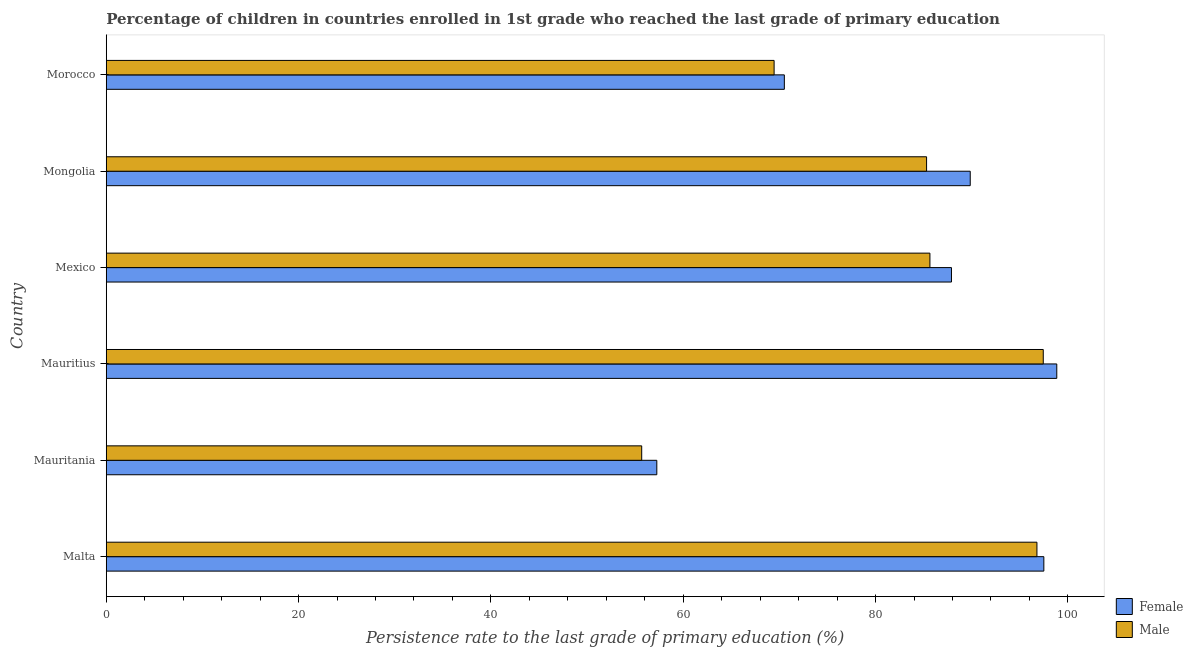Are the number of bars on each tick of the Y-axis equal?
Provide a succinct answer. Yes. How many bars are there on the 5th tick from the top?
Ensure brevity in your answer.  2. What is the label of the 1st group of bars from the top?
Your answer should be compact. Morocco. In how many cases, is the number of bars for a given country not equal to the number of legend labels?
Offer a very short reply. 0. What is the persistence rate of male students in Morocco?
Make the answer very short. 69.45. Across all countries, what is the maximum persistence rate of female students?
Your response must be concise. 98.84. Across all countries, what is the minimum persistence rate of female students?
Provide a short and direct response. 57.25. In which country was the persistence rate of male students maximum?
Make the answer very short. Mauritius. In which country was the persistence rate of male students minimum?
Make the answer very short. Mauritania. What is the total persistence rate of female students in the graph?
Provide a succinct answer. 501.84. What is the difference between the persistence rate of male students in Malta and that in Mauritius?
Your answer should be compact. -0.66. What is the difference between the persistence rate of female students in Malta and the persistence rate of male students in Mauritius?
Make the answer very short. 0.06. What is the average persistence rate of female students per country?
Your answer should be compact. 83.64. What is the difference between the persistence rate of male students and persistence rate of female students in Malta?
Ensure brevity in your answer.  -0.72. In how many countries, is the persistence rate of male students greater than 36 %?
Give a very brief answer. 6. Is the difference between the persistence rate of female students in Mauritania and Mongolia greater than the difference between the persistence rate of male students in Mauritania and Mongolia?
Give a very brief answer. No. What is the difference between the highest and the second highest persistence rate of female students?
Your answer should be compact. 1.34. What is the difference between the highest and the lowest persistence rate of female students?
Offer a terse response. 41.59. In how many countries, is the persistence rate of female students greater than the average persistence rate of female students taken over all countries?
Your answer should be very brief. 4. What does the 2nd bar from the top in Malta represents?
Your answer should be compact. Female. What is the difference between two consecutive major ticks on the X-axis?
Your answer should be compact. 20. Does the graph contain grids?
Make the answer very short. No. How are the legend labels stacked?
Offer a very short reply. Vertical. What is the title of the graph?
Make the answer very short. Percentage of children in countries enrolled in 1st grade who reached the last grade of primary education. What is the label or title of the X-axis?
Make the answer very short. Persistence rate to the last grade of primary education (%). What is the label or title of the Y-axis?
Make the answer very short. Country. What is the Persistence rate to the last grade of primary education (%) in Female in Malta?
Offer a terse response. 97.5. What is the Persistence rate to the last grade of primary education (%) of Male in Malta?
Offer a terse response. 96.78. What is the Persistence rate to the last grade of primary education (%) of Female in Mauritania?
Your answer should be compact. 57.25. What is the Persistence rate to the last grade of primary education (%) in Male in Mauritania?
Ensure brevity in your answer.  55.68. What is the Persistence rate to the last grade of primary education (%) of Female in Mauritius?
Offer a very short reply. 98.84. What is the Persistence rate to the last grade of primary education (%) in Male in Mauritius?
Provide a succinct answer. 97.44. What is the Persistence rate to the last grade of primary education (%) of Female in Mexico?
Give a very brief answer. 87.89. What is the Persistence rate to the last grade of primary education (%) in Male in Mexico?
Give a very brief answer. 85.65. What is the Persistence rate to the last grade of primary education (%) in Female in Mongolia?
Offer a very short reply. 89.84. What is the Persistence rate to the last grade of primary education (%) in Male in Mongolia?
Give a very brief answer. 85.3. What is the Persistence rate to the last grade of primary education (%) of Female in Morocco?
Provide a succinct answer. 70.51. What is the Persistence rate to the last grade of primary education (%) in Male in Morocco?
Offer a terse response. 69.45. Across all countries, what is the maximum Persistence rate to the last grade of primary education (%) of Female?
Keep it short and to the point. 98.84. Across all countries, what is the maximum Persistence rate to the last grade of primary education (%) of Male?
Give a very brief answer. 97.44. Across all countries, what is the minimum Persistence rate to the last grade of primary education (%) of Female?
Provide a succinct answer. 57.25. Across all countries, what is the minimum Persistence rate to the last grade of primary education (%) in Male?
Offer a terse response. 55.68. What is the total Persistence rate to the last grade of primary education (%) of Female in the graph?
Give a very brief answer. 501.84. What is the total Persistence rate to the last grade of primary education (%) of Male in the graph?
Provide a short and direct response. 490.3. What is the difference between the Persistence rate to the last grade of primary education (%) of Female in Malta and that in Mauritania?
Keep it short and to the point. 40.25. What is the difference between the Persistence rate to the last grade of primary education (%) of Male in Malta and that in Mauritania?
Ensure brevity in your answer.  41.1. What is the difference between the Persistence rate to the last grade of primary education (%) of Female in Malta and that in Mauritius?
Your response must be concise. -1.34. What is the difference between the Persistence rate to the last grade of primary education (%) of Male in Malta and that in Mauritius?
Offer a terse response. -0.66. What is the difference between the Persistence rate to the last grade of primary education (%) of Female in Malta and that in Mexico?
Your answer should be compact. 9.61. What is the difference between the Persistence rate to the last grade of primary education (%) of Male in Malta and that in Mexico?
Make the answer very short. 11.13. What is the difference between the Persistence rate to the last grade of primary education (%) in Female in Malta and that in Mongolia?
Make the answer very short. 7.65. What is the difference between the Persistence rate to the last grade of primary education (%) of Male in Malta and that in Mongolia?
Your answer should be compact. 11.48. What is the difference between the Persistence rate to the last grade of primary education (%) in Female in Malta and that in Morocco?
Your answer should be compact. 26.98. What is the difference between the Persistence rate to the last grade of primary education (%) in Male in Malta and that in Morocco?
Offer a terse response. 27.33. What is the difference between the Persistence rate to the last grade of primary education (%) of Female in Mauritania and that in Mauritius?
Make the answer very short. -41.59. What is the difference between the Persistence rate to the last grade of primary education (%) in Male in Mauritania and that in Mauritius?
Offer a terse response. -41.76. What is the difference between the Persistence rate to the last grade of primary education (%) in Female in Mauritania and that in Mexico?
Offer a terse response. -30.64. What is the difference between the Persistence rate to the last grade of primary education (%) of Male in Mauritania and that in Mexico?
Give a very brief answer. -29.97. What is the difference between the Persistence rate to the last grade of primary education (%) of Female in Mauritania and that in Mongolia?
Keep it short and to the point. -32.59. What is the difference between the Persistence rate to the last grade of primary education (%) of Male in Mauritania and that in Mongolia?
Provide a short and direct response. -29.62. What is the difference between the Persistence rate to the last grade of primary education (%) in Female in Mauritania and that in Morocco?
Provide a succinct answer. -13.26. What is the difference between the Persistence rate to the last grade of primary education (%) of Male in Mauritania and that in Morocco?
Offer a very short reply. -13.77. What is the difference between the Persistence rate to the last grade of primary education (%) of Female in Mauritius and that in Mexico?
Offer a terse response. 10.95. What is the difference between the Persistence rate to the last grade of primary education (%) of Male in Mauritius and that in Mexico?
Offer a very short reply. 11.79. What is the difference between the Persistence rate to the last grade of primary education (%) in Female in Mauritius and that in Mongolia?
Keep it short and to the point. 9. What is the difference between the Persistence rate to the last grade of primary education (%) of Male in Mauritius and that in Mongolia?
Your response must be concise. 12.13. What is the difference between the Persistence rate to the last grade of primary education (%) in Female in Mauritius and that in Morocco?
Offer a terse response. 28.33. What is the difference between the Persistence rate to the last grade of primary education (%) in Male in Mauritius and that in Morocco?
Your response must be concise. 27.99. What is the difference between the Persistence rate to the last grade of primary education (%) in Female in Mexico and that in Mongolia?
Offer a terse response. -1.95. What is the difference between the Persistence rate to the last grade of primary education (%) of Male in Mexico and that in Mongolia?
Ensure brevity in your answer.  0.35. What is the difference between the Persistence rate to the last grade of primary education (%) of Female in Mexico and that in Morocco?
Offer a terse response. 17.38. What is the difference between the Persistence rate to the last grade of primary education (%) in Male in Mexico and that in Morocco?
Ensure brevity in your answer.  16.2. What is the difference between the Persistence rate to the last grade of primary education (%) in Female in Mongolia and that in Morocco?
Keep it short and to the point. 19.33. What is the difference between the Persistence rate to the last grade of primary education (%) of Male in Mongolia and that in Morocco?
Give a very brief answer. 15.85. What is the difference between the Persistence rate to the last grade of primary education (%) in Female in Malta and the Persistence rate to the last grade of primary education (%) in Male in Mauritania?
Your answer should be very brief. 41.82. What is the difference between the Persistence rate to the last grade of primary education (%) of Female in Malta and the Persistence rate to the last grade of primary education (%) of Male in Mauritius?
Give a very brief answer. 0.06. What is the difference between the Persistence rate to the last grade of primary education (%) of Female in Malta and the Persistence rate to the last grade of primary education (%) of Male in Mexico?
Provide a succinct answer. 11.85. What is the difference between the Persistence rate to the last grade of primary education (%) in Female in Malta and the Persistence rate to the last grade of primary education (%) in Male in Mongolia?
Your answer should be very brief. 12.19. What is the difference between the Persistence rate to the last grade of primary education (%) of Female in Malta and the Persistence rate to the last grade of primary education (%) of Male in Morocco?
Offer a terse response. 28.05. What is the difference between the Persistence rate to the last grade of primary education (%) in Female in Mauritania and the Persistence rate to the last grade of primary education (%) in Male in Mauritius?
Offer a terse response. -40.19. What is the difference between the Persistence rate to the last grade of primary education (%) of Female in Mauritania and the Persistence rate to the last grade of primary education (%) of Male in Mexico?
Provide a succinct answer. -28.4. What is the difference between the Persistence rate to the last grade of primary education (%) of Female in Mauritania and the Persistence rate to the last grade of primary education (%) of Male in Mongolia?
Your answer should be very brief. -28.05. What is the difference between the Persistence rate to the last grade of primary education (%) in Female in Mauritania and the Persistence rate to the last grade of primary education (%) in Male in Morocco?
Ensure brevity in your answer.  -12.2. What is the difference between the Persistence rate to the last grade of primary education (%) in Female in Mauritius and the Persistence rate to the last grade of primary education (%) in Male in Mexico?
Ensure brevity in your answer.  13.19. What is the difference between the Persistence rate to the last grade of primary education (%) of Female in Mauritius and the Persistence rate to the last grade of primary education (%) of Male in Mongolia?
Offer a terse response. 13.54. What is the difference between the Persistence rate to the last grade of primary education (%) of Female in Mauritius and the Persistence rate to the last grade of primary education (%) of Male in Morocco?
Your answer should be compact. 29.39. What is the difference between the Persistence rate to the last grade of primary education (%) of Female in Mexico and the Persistence rate to the last grade of primary education (%) of Male in Mongolia?
Provide a succinct answer. 2.59. What is the difference between the Persistence rate to the last grade of primary education (%) in Female in Mexico and the Persistence rate to the last grade of primary education (%) in Male in Morocco?
Your answer should be very brief. 18.44. What is the difference between the Persistence rate to the last grade of primary education (%) of Female in Mongolia and the Persistence rate to the last grade of primary education (%) of Male in Morocco?
Give a very brief answer. 20.39. What is the average Persistence rate to the last grade of primary education (%) of Female per country?
Make the answer very short. 83.64. What is the average Persistence rate to the last grade of primary education (%) in Male per country?
Your response must be concise. 81.72. What is the difference between the Persistence rate to the last grade of primary education (%) of Female and Persistence rate to the last grade of primary education (%) of Male in Malta?
Ensure brevity in your answer.  0.72. What is the difference between the Persistence rate to the last grade of primary education (%) in Female and Persistence rate to the last grade of primary education (%) in Male in Mauritania?
Provide a succinct answer. 1.57. What is the difference between the Persistence rate to the last grade of primary education (%) in Female and Persistence rate to the last grade of primary education (%) in Male in Mauritius?
Your answer should be very brief. 1.41. What is the difference between the Persistence rate to the last grade of primary education (%) in Female and Persistence rate to the last grade of primary education (%) in Male in Mexico?
Give a very brief answer. 2.24. What is the difference between the Persistence rate to the last grade of primary education (%) of Female and Persistence rate to the last grade of primary education (%) of Male in Mongolia?
Provide a succinct answer. 4.54. What is the difference between the Persistence rate to the last grade of primary education (%) in Female and Persistence rate to the last grade of primary education (%) in Male in Morocco?
Offer a terse response. 1.06. What is the ratio of the Persistence rate to the last grade of primary education (%) of Female in Malta to that in Mauritania?
Provide a succinct answer. 1.7. What is the ratio of the Persistence rate to the last grade of primary education (%) in Male in Malta to that in Mauritania?
Give a very brief answer. 1.74. What is the ratio of the Persistence rate to the last grade of primary education (%) in Female in Malta to that in Mauritius?
Provide a succinct answer. 0.99. What is the ratio of the Persistence rate to the last grade of primary education (%) of Male in Malta to that in Mauritius?
Provide a short and direct response. 0.99. What is the ratio of the Persistence rate to the last grade of primary education (%) in Female in Malta to that in Mexico?
Give a very brief answer. 1.11. What is the ratio of the Persistence rate to the last grade of primary education (%) in Male in Malta to that in Mexico?
Offer a very short reply. 1.13. What is the ratio of the Persistence rate to the last grade of primary education (%) in Female in Malta to that in Mongolia?
Keep it short and to the point. 1.09. What is the ratio of the Persistence rate to the last grade of primary education (%) of Male in Malta to that in Mongolia?
Provide a short and direct response. 1.13. What is the ratio of the Persistence rate to the last grade of primary education (%) in Female in Malta to that in Morocco?
Keep it short and to the point. 1.38. What is the ratio of the Persistence rate to the last grade of primary education (%) of Male in Malta to that in Morocco?
Offer a terse response. 1.39. What is the ratio of the Persistence rate to the last grade of primary education (%) in Female in Mauritania to that in Mauritius?
Your response must be concise. 0.58. What is the ratio of the Persistence rate to the last grade of primary education (%) of Male in Mauritania to that in Mauritius?
Keep it short and to the point. 0.57. What is the ratio of the Persistence rate to the last grade of primary education (%) in Female in Mauritania to that in Mexico?
Ensure brevity in your answer.  0.65. What is the ratio of the Persistence rate to the last grade of primary education (%) in Male in Mauritania to that in Mexico?
Keep it short and to the point. 0.65. What is the ratio of the Persistence rate to the last grade of primary education (%) of Female in Mauritania to that in Mongolia?
Give a very brief answer. 0.64. What is the ratio of the Persistence rate to the last grade of primary education (%) in Male in Mauritania to that in Mongolia?
Your answer should be very brief. 0.65. What is the ratio of the Persistence rate to the last grade of primary education (%) of Female in Mauritania to that in Morocco?
Your answer should be compact. 0.81. What is the ratio of the Persistence rate to the last grade of primary education (%) of Male in Mauritania to that in Morocco?
Keep it short and to the point. 0.8. What is the ratio of the Persistence rate to the last grade of primary education (%) in Female in Mauritius to that in Mexico?
Your answer should be very brief. 1.12. What is the ratio of the Persistence rate to the last grade of primary education (%) in Male in Mauritius to that in Mexico?
Make the answer very short. 1.14. What is the ratio of the Persistence rate to the last grade of primary education (%) of Female in Mauritius to that in Mongolia?
Offer a very short reply. 1.1. What is the ratio of the Persistence rate to the last grade of primary education (%) in Male in Mauritius to that in Mongolia?
Your answer should be compact. 1.14. What is the ratio of the Persistence rate to the last grade of primary education (%) of Female in Mauritius to that in Morocco?
Offer a terse response. 1.4. What is the ratio of the Persistence rate to the last grade of primary education (%) of Male in Mauritius to that in Morocco?
Offer a terse response. 1.4. What is the ratio of the Persistence rate to the last grade of primary education (%) in Female in Mexico to that in Mongolia?
Offer a terse response. 0.98. What is the ratio of the Persistence rate to the last grade of primary education (%) of Female in Mexico to that in Morocco?
Your answer should be very brief. 1.25. What is the ratio of the Persistence rate to the last grade of primary education (%) of Male in Mexico to that in Morocco?
Your response must be concise. 1.23. What is the ratio of the Persistence rate to the last grade of primary education (%) of Female in Mongolia to that in Morocco?
Ensure brevity in your answer.  1.27. What is the ratio of the Persistence rate to the last grade of primary education (%) in Male in Mongolia to that in Morocco?
Make the answer very short. 1.23. What is the difference between the highest and the second highest Persistence rate to the last grade of primary education (%) in Female?
Provide a short and direct response. 1.34. What is the difference between the highest and the second highest Persistence rate to the last grade of primary education (%) of Male?
Make the answer very short. 0.66. What is the difference between the highest and the lowest Persistence rate to the last grade of primary education (%) in Female?
Keep it short and to the point. 41.59. What is the difference between the highest and the lowest Persistence rate to the last grade of primary education (%) of Male?
Give a very brief answer. 41.76. 